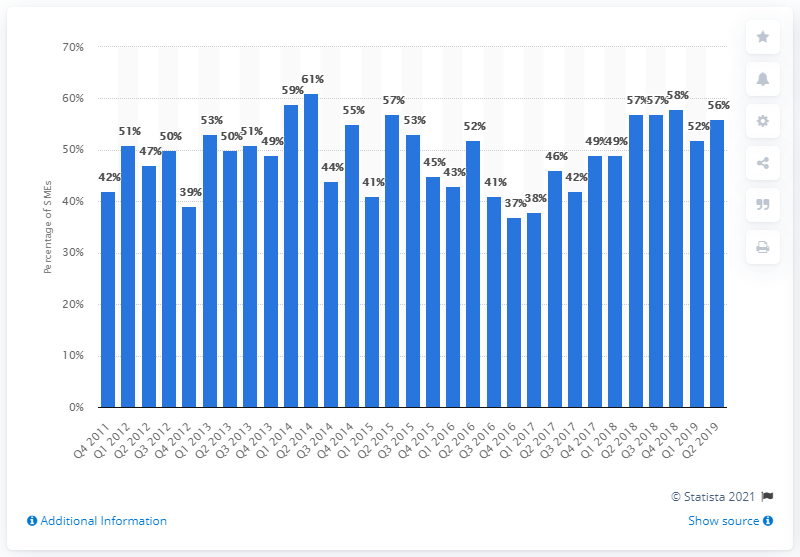Specify some key components in this picture. In the second quarter of 2019, the manufacturing sector SMEs accounted for 56% of the total output. According to the survey of manufacturing sector SMEs, 61% of them stated that they plan to grow in the next 12 months. 